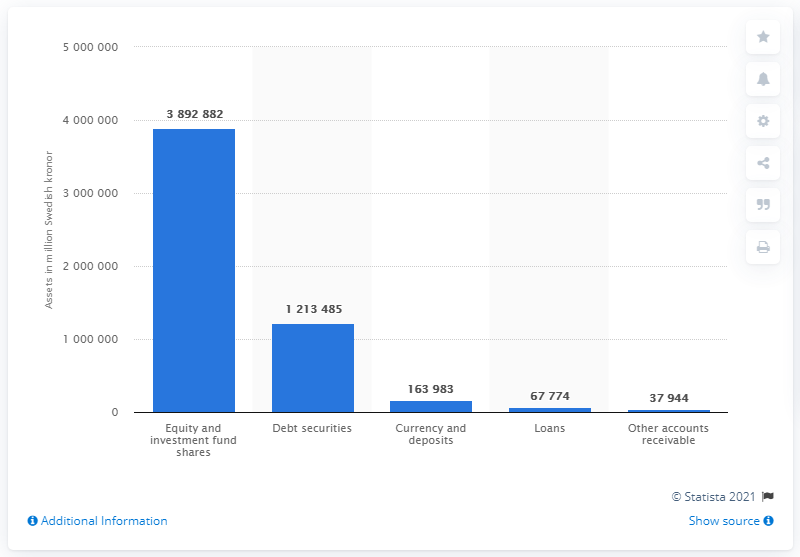Draw attention to some important aspects in this diagram. In 2019, the total value of equity and investment fund shares owned by pension funds in Sweden was SEK 389,288,200. 